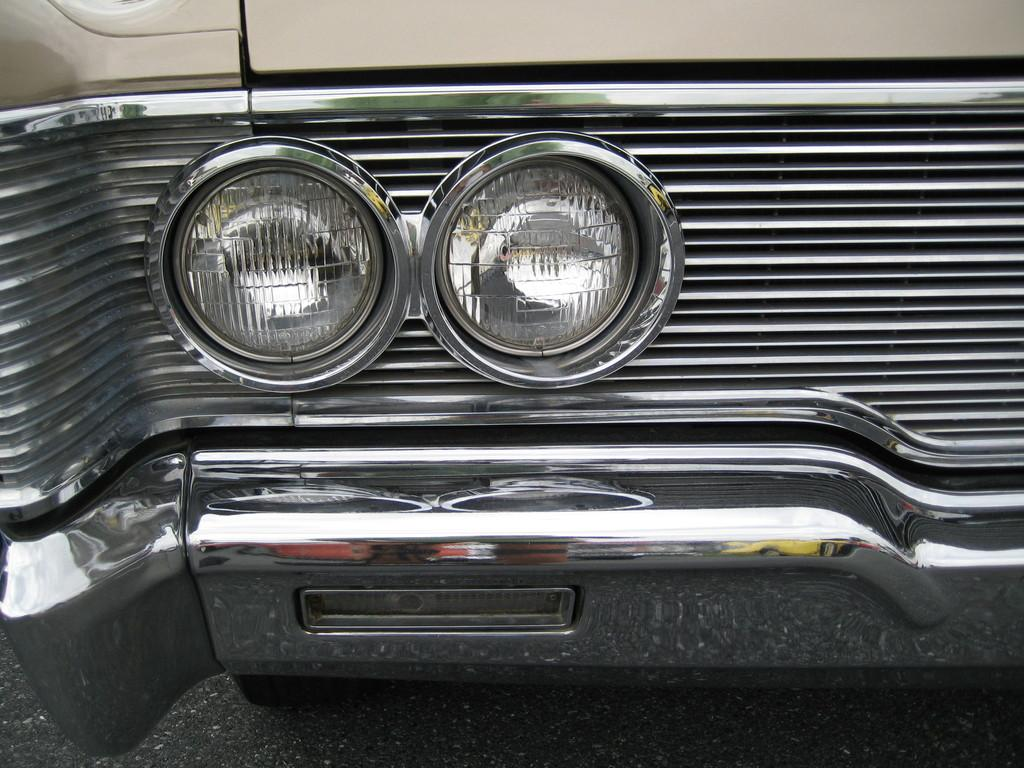What is the main feature of the image? The main feature of the image is the headlights of a vehicle. What can be seen below the headlights in the image? There is a road visible at the bottom of the image. What type of material surrounds the headlights? There is a metal object surrounding the headlights. What type of attraction can be seen in the background of the image? There is no attraction visible in the background of the image; it only features the headlights, road, and metal object. 